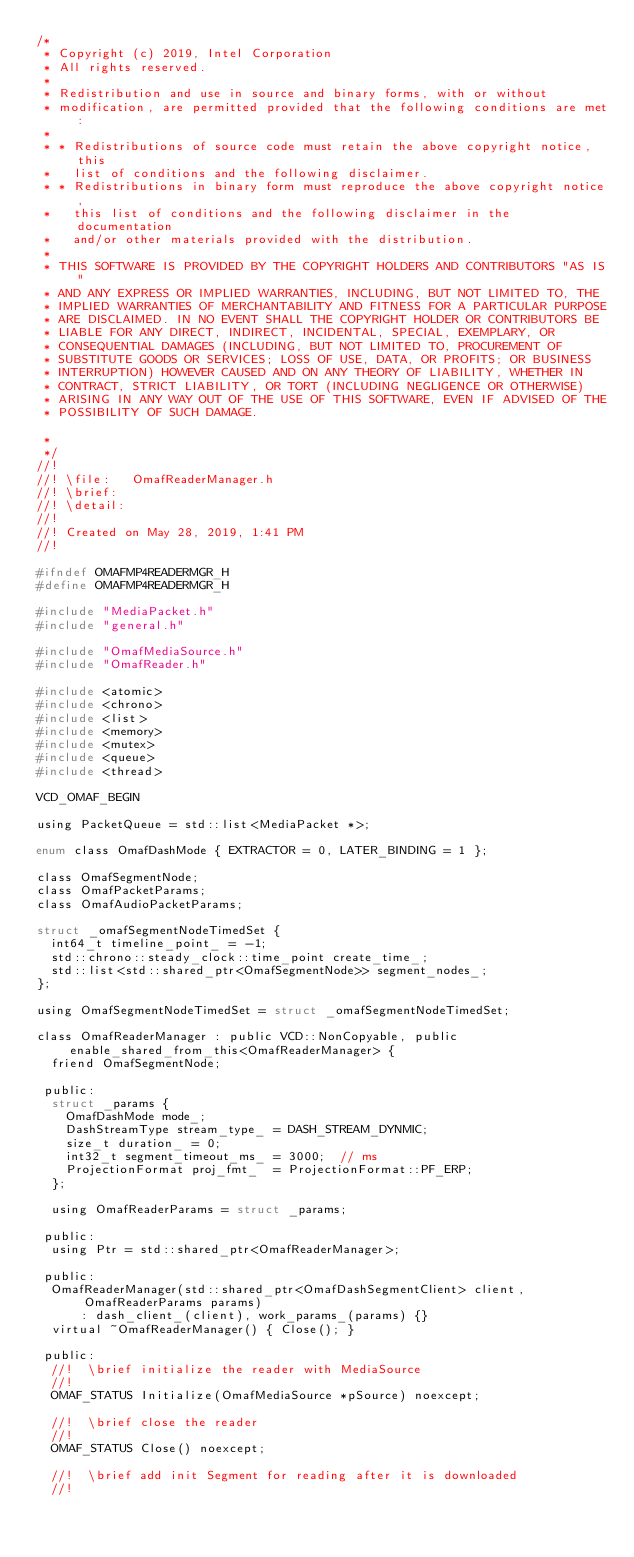<code> <loc_0><loc_0><loc_500><loc_500><_C_>/*
 * Copyright (c) 2019, Intel Corporation
 * All rights reserved.
 *
 * Redistribution and use in source and binary forms, with or without
 * modification, are permitted provided that the following conditions are met:
 *
 * * Redistributions of source code must retain the above copyright notice, this
 *   list of conditions and the following disclaimer.
 * * Redistributions in binary form must reproduce the above copyright notice,
 *   this list of conditions and the following disclaimer in the documentation
 *   and/or other materials provided with the distribution.
 *
 * THIS SOFTWARE IS PROVIDED BY THE COPYRIGHT HOLDERS AND CONTRIBUTORS "AS IS"
 * AND ANY EXPRESS OR IMPLIED WARRANTIES, INCLUDING, BUT NOT LIMITED TO, THE
 * IMPLIED WARRANTIES OF MERCHANTABILITY AND FITNESS FOR A PARTICULAR PURPOSE
 * ARE DISCLAIMED. IN NO EVENT SHALL THE COPYRIGHT HOLDER OR CONTRIBUTORS BE
 * LIABLE FOR ANY DIRECT, INDIRECT, INCIDENTAL, SPECIAL, EXEMPLARY, OR
 * CONSEQUENTIAL DAMAGES (INCLUDING, BUT NOT LIMITED TO, PROCUREMENT OF
 * SUBSTITUTE GOODS OR SERVICES; LOSS OF USE, DATA, OR PROFITS; OR BUSINESS
 * INTERRUPTION) HOWEVER CAUSED AND ON ANY THEORY OF LIABILITY, WHETHER IN
 * CONTRACT, STRICT LIABILITY, OR TORT (INCLUDING NEGLIGENCE OR OTHERWISE)
 * ARISING IN ANY WAY OUT OF THE USE OF THIS SOFTWARE, EVEN IF ADVISED OF THE
 * POSSIBILITY OF SUCH DAMAGE.

 *
 */
//!
//! \file:   OmafReaderManager.h
//! \brief:
//! \detail:
//!
//! Created on May 28, 2019, 1:41 PM
//!

#ifndef OMAFMP4READERMGR_H
#define OMAFMP4READERMGR_H

#include "MediaPacket.h"
#include "general.h"

#include "OmafMediaSource.h"
#include "OmafReader.h"

#include <atomic>
#include <chrono>
#include <list>
#include <memory>
#include <mutex>
#include <queue>
#include <thread>

VCD_OMAF_BEGIN

using PacketQueue = std::list<MediaPacket *>;

enum class OmafDashMode { EXTRACTOR = 0, LATER_BINDING = 1 };

class OmafSegmentNode;
class OmafPacketParams;
class OmafAudioPacketParams;

struct _omafSegmentNodeTimedSet {
  int64_t timeline_point_ = -1;
  std::chrono::steady_clock::time_point create_time_;
  std::list<std::shared_ptr<OmafSegmentNode>> segment_nodes_;
};

using OmafSegmentNodeTimedSet = struct _omafSegmentNodeTimedSet;

class OmafReaderManager : public VCD::NonCopyable, public enable_shared_from_this<OmafReaderManager> {
  friend OmafSegmentNode;

 public:
  struct _params {
    OmafDashMode mode_;
    DashStreamType stream_type_ = DASH_STREAM_DYNMIC;
    size_t duration_ = 0;
    int32_t segment_timeout_ms_ = 3000;  // ms
    ProjectionFormat proj_fmt_  = ProjectionFormat::PF_ERP;
  };

  using OmafReaderParams = struct _params;

 public:
  using Ptr = std::shared_ptr<OmafReaderManager>;

 public:
  OmafReaderManager(std::shared_ptr<OmafDashSegmentClient> client, OmafReaderParams params)
      : dash_client_(client), work_params_(params) {}
  virtual ~OmafReaderManager() { Close(); }

 public:
  //!  \brief initialize the reader with MediaSource
  //!
  OMAF_STATUS Initialize(OmafMediaSource *pSource) noexcept;

  //!  \brief close the reader
  //!
  OMAF_STATUS Close() noexcept;

  //!  \brief add init Segment for reading after it is downloaded
  //!</code> 